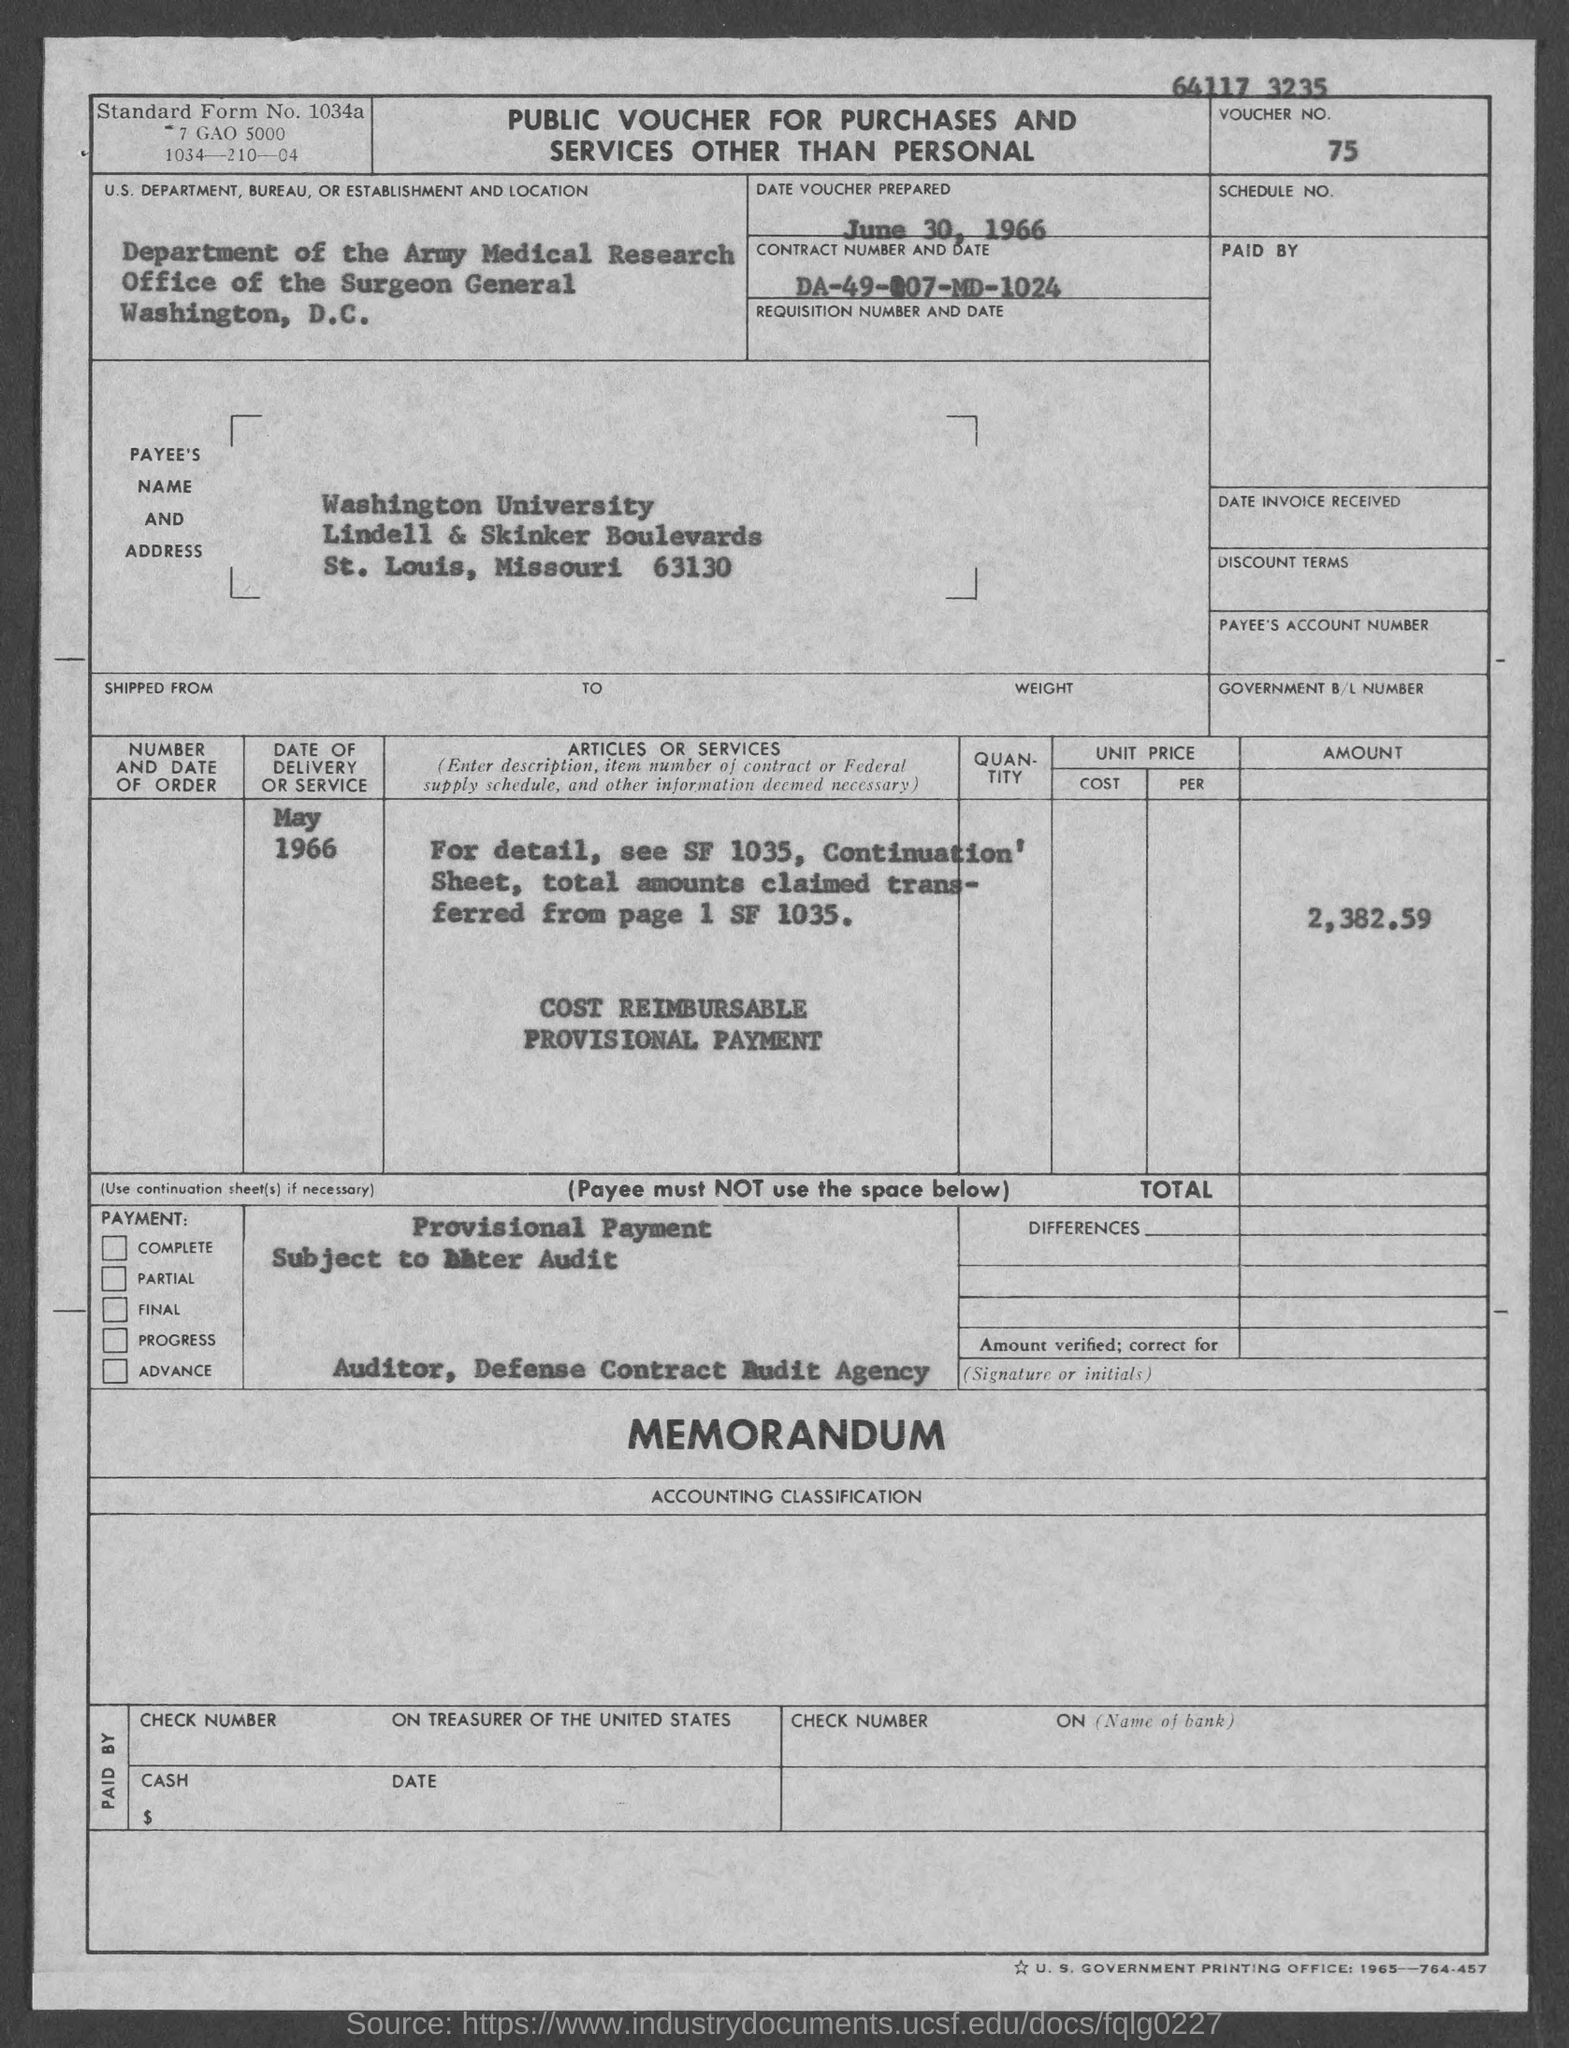List a handful of essential elements in this visual. The date of the voucher is June 30, 1966. The contract number is DA-49-007-MD-1024 and the date is... The voucher number is 75. The date of delivery or service was May 1966. The amount is 2,382.59. 